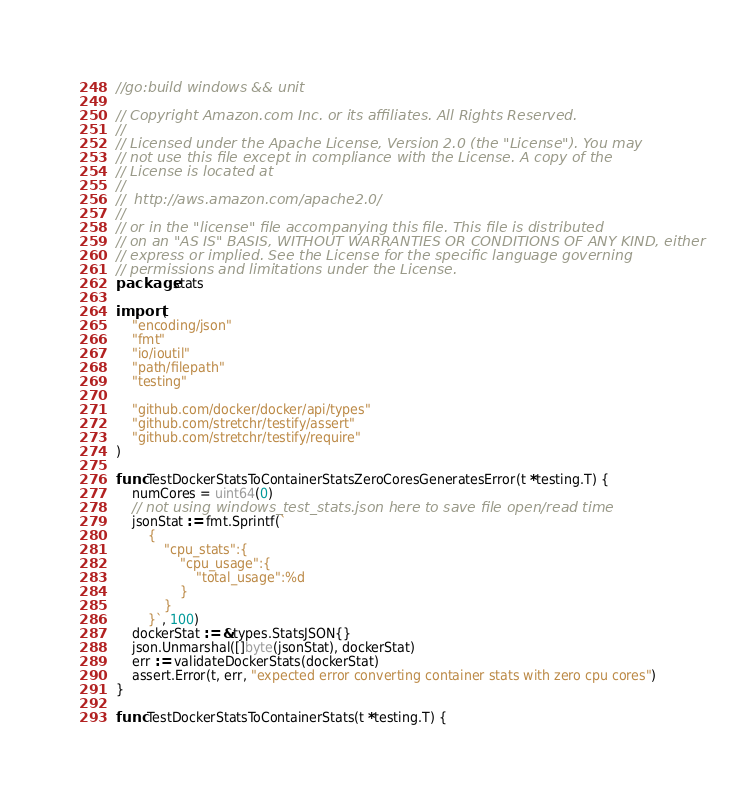Convert code to text. <code><loc_0><loc_0><loc_500><loc_500><_Go_>//go:build windows && unit

// Copyright Amazon.com Inc. or its affiliates. All Rights Reserved.
//
// Licensed under the Apache License, Version 2.0 (the "License"). You may
// not use this file except in compliance with the License. A copy of the
// License is located at
//
//	http://aws.amazon.com/apache2.0/
//
// or in the "license" file accompanying this file. This file is distributed
// on an "AS IS" BASIS, WITHOUT WARRANTIES OR CONDITIONS OF ANY KIND, either
// express or implied. See the License for the specific language governing
// permissions and limitations under the License.
package stats

import (
	"encoding/json"
	"fmt"
	"io/ioutil"
	"path/filepath"
	"testing"

	"github.com/docker/docker/api/types"
	"github.com/stretchr/testify/assert"
	"github.com/stretchr/testify/require"
)

func TestDockerStatsToContainerStatsZeroCoresGeneratesError(t *testing.T) {
	numCores = uint64(0)
	// not using windows_test_stats.json here to save file open/read time
	jsonStat := fmt.Sprintf(`
		{
			"cpu_stats":{
				"cpu_usage":{
					"total_usage":%d
				}
			}
		}`, 100)
	dockerStat := &types.StatsJSON{}
	json.Unmarshal([]byte(jsonStat), dockerStat)
	err := validateDockerStats(dockerStat)
	assert.Error(t, err, "expected error converting container stats with zero cpu cores")
}

func TestDockerStatsToContainerStats(t *testing.T) {</code> 